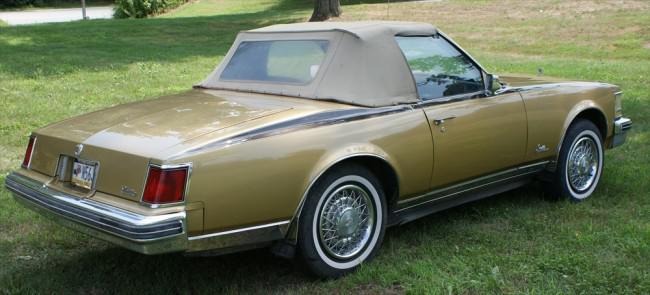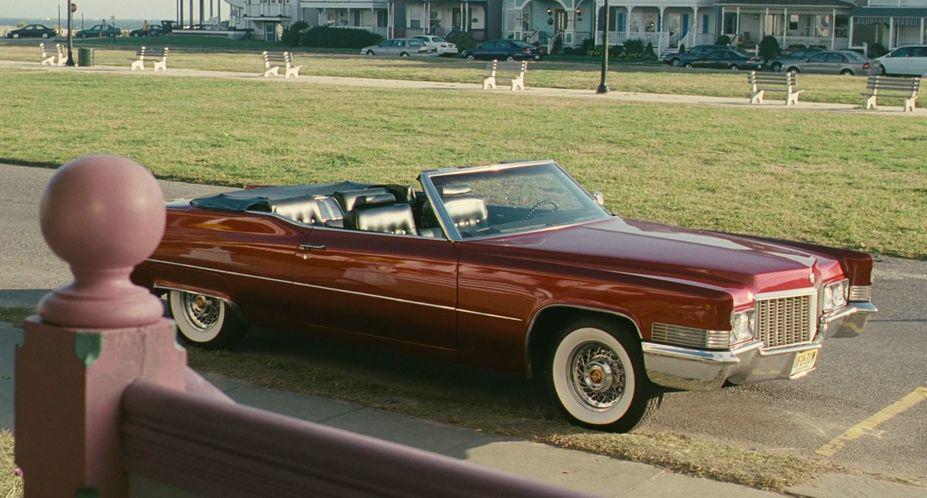The first image is the image on the left, the second image is the image on the right. For the images shown, is this caption "1 car has it's convertible top up." true? Answer yes or no. Yes. The first image is the image on the left, the second image is the image on the right. Considering the images on both sides, is "In one image exactly one convertible car is on the grass." valid? Answer yes or no. Yes. 